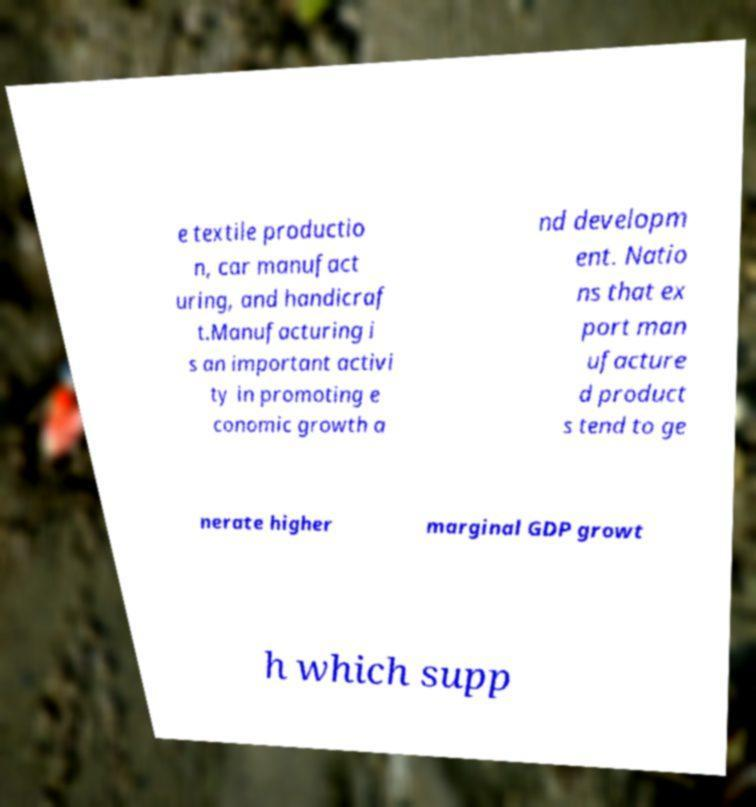Could you assist in decoding the text presented in this image and type it out clearly? e textile productio n, car manufact uring, and handicraf t.Manufacturing i s an important activi ty in promoting e conomic growth a nd developm ent. Natio ns that ex port man ufacture d product s tend to ge nerate higher marginal GDP growt h which supp 